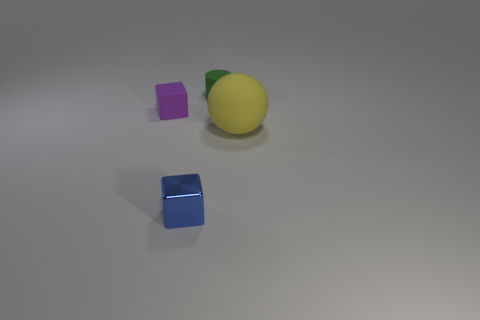What materials do the objects in the image seem to be made of? The sphere looks like it's made of rubber due to its matte texture and slight sheen. The green object appears to be plastic because of its solid color and reflective surface. The two cubes have a solid, possibly metallic appearance based on their sharp reflections and clean edges. 